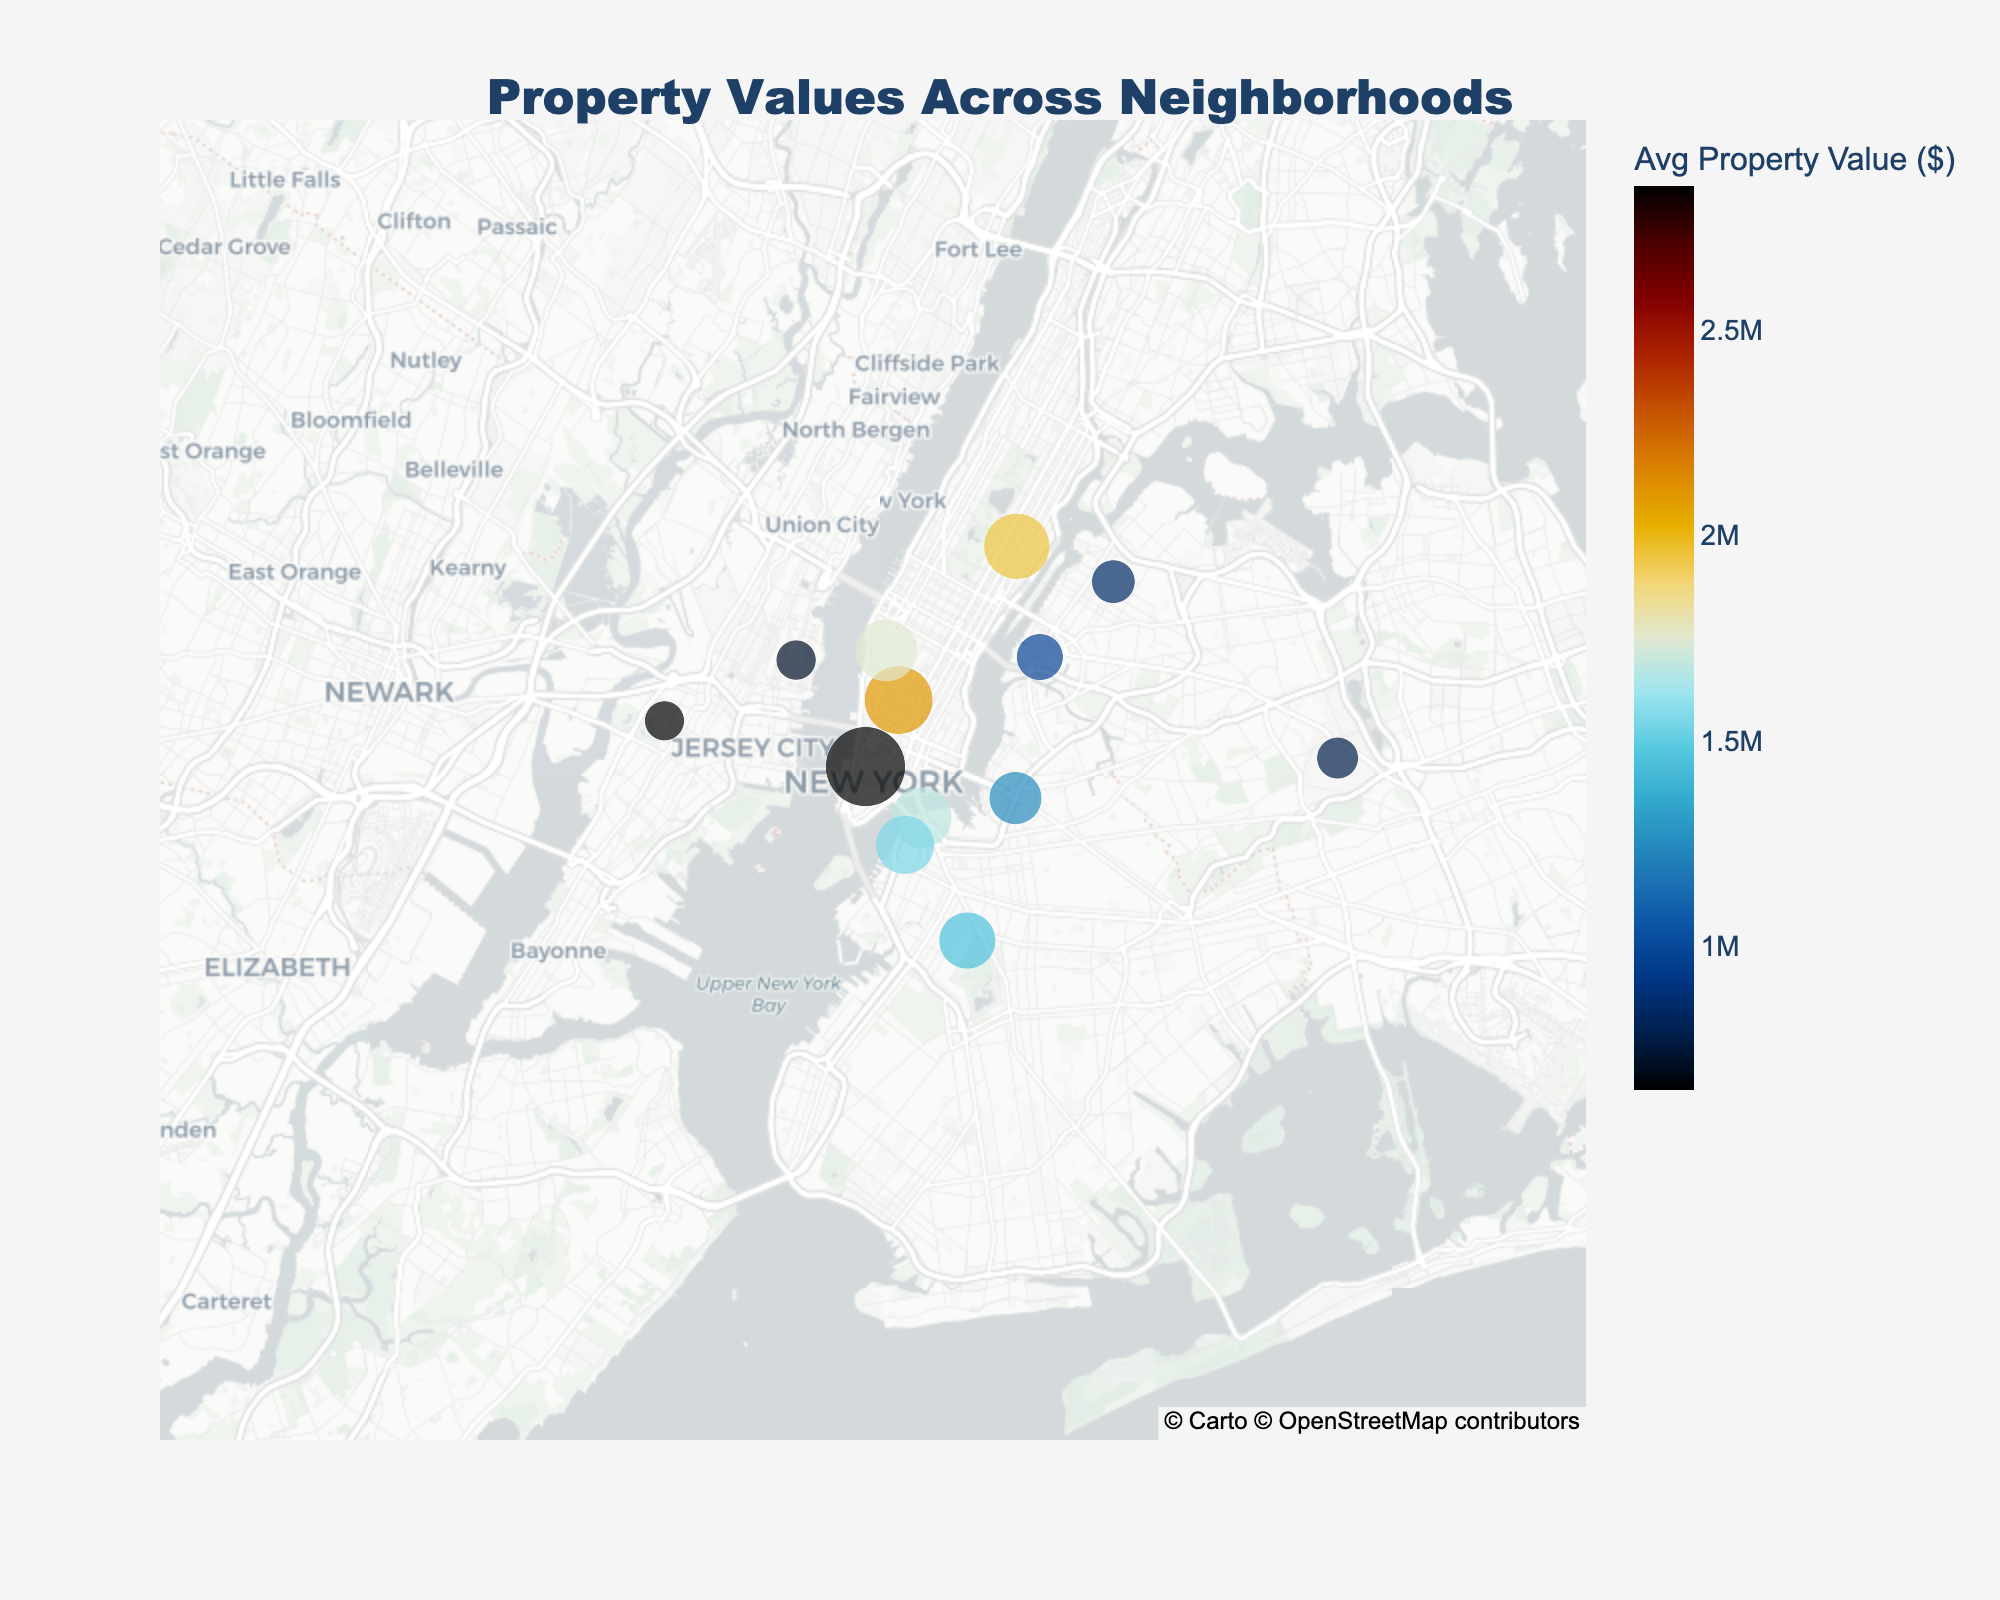What's the title of the figure? The title is located at the top center of the figure and read as "Property Values Across Neighborhoods."
Answer: Property Values Across Neighborhoods How many neighborhoods are represented in the map? By counting the number of data points on the map, there are 13 neighborhoods represented.
Answer: 13 Which neighborhood has the highest average property value? By observing the color and size of markers, Tribeca clearly stands out with the highest average property value.
Answer: Tribeca Which neighborhood has the smallest average property value? The smallest marker with the least intense color is Jersey City, indicating the lowest average property value.
Answer: Jersey City What is the average property value in Greenwich Village? By hovering over the marker for Greenwich Village, the hover text shows it has an average property value of $2,100,000.
Answer: $2,100,000 What's the difference in the average property values between Park Slope and Dumbo? Park Slope has an average property value of $1,450,000, and Dumbo has $1,680,000. The difference is $1,680,000 - $1,450,000.
Answer: $230,000 Which neighborhood has a higher average property value, Chelsea or Upper East Side? By comparing the markers, Upper East Side has an average property value of $1,950,000, higher than Chelsea's $1,750,000.
Answer: Upper East Side How does the color scheme help in interpreting property values? The color scheme uses continuous color variations to represent different average property values, helping to visually distinguish high-value and low-value neighborhoods.
Answer: It uses color variations What is the approximate latitude and longitude of Williamsburg? By referring to the hover text for Williamsburg, its coordinates approximately are 40.7081°N latitude and -73.9571°W longitude.
Answer: 40.7081°N, -73.9571°W Which neighborhoods have average property values greater than $1,500,000? By observing the markers with higher colors and sizes, Tribeca, Upper East Side, Dumbo, Greenwich Village, and Chelsea have property values greater than $1,500,000.
Answer: Tribeca, Upper East Side, Dumbo, Greenwich Village, Chelsea 